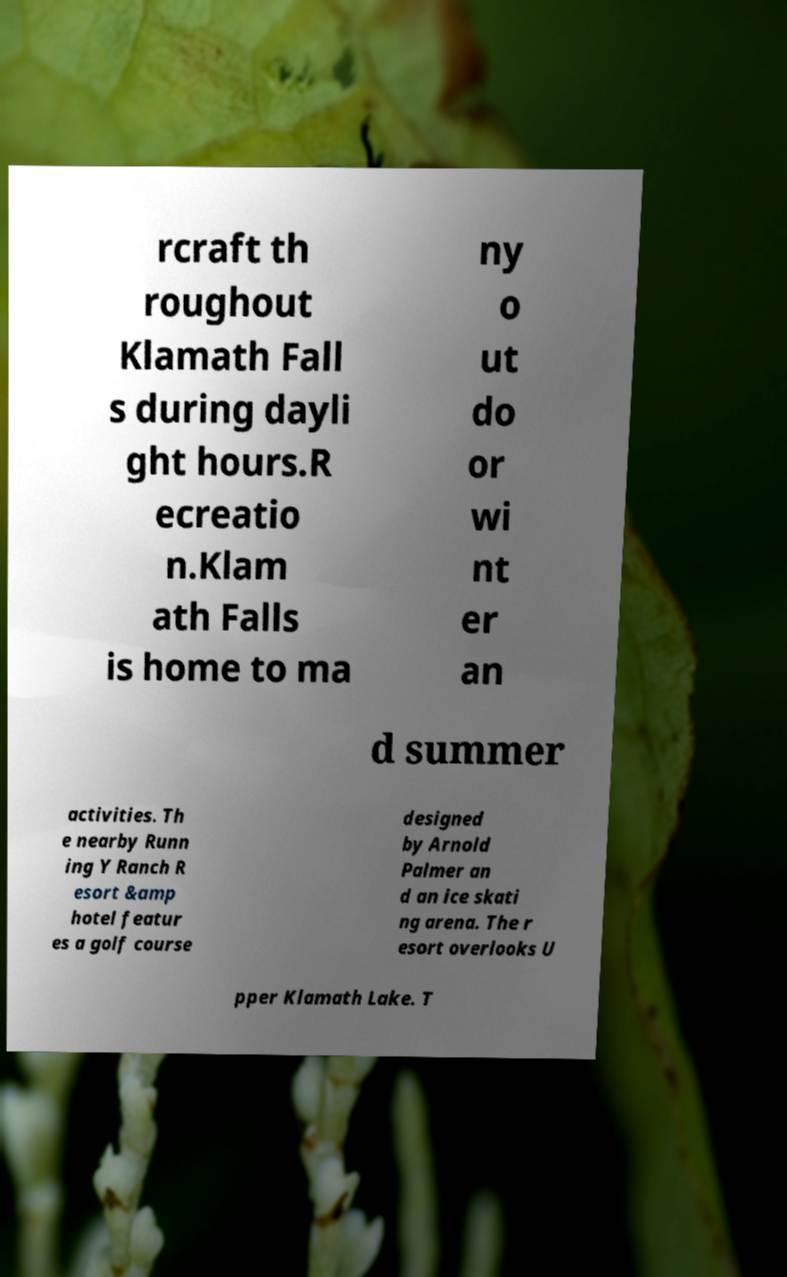For documentation purposes, I need the text within this image transcribed. Could you provide that? rcraft th roughout Klamath Fall s during dayli ght hours.R ecreatio n.Klam ath Falls is home to ma ny o ut do or wi nt er an d summer activities. Th e nearby Runn ing Y Ranch R esort &amp hotel featur es a golf course designed by Arnold Palmer an d an ice skati ng arena. The r esort overlooks U pper Klamath Lake. T 